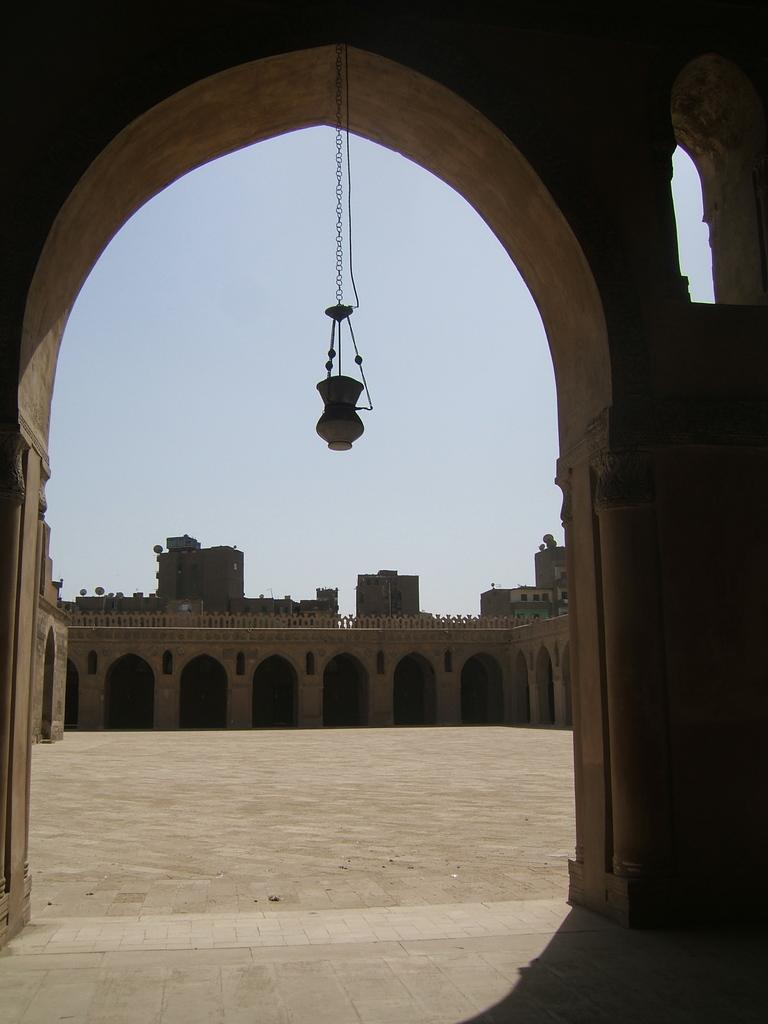What is hanging in the image? There is an object hanging in the image. What type of architecture can be seen in the image? The image contains ancient architecture. What can be seen on the ground in the image? The ground is visible in the image. What is visible in the background of the image? There are buildings and the sky visible in the background of the image. What type of soda is being served in the image? There is no soda present in the image; it features an object hanging and ancient architecture. Can you see the sister of the person taking the photo in the image? There is no person taking the photo or any reference to a sister in the image. 